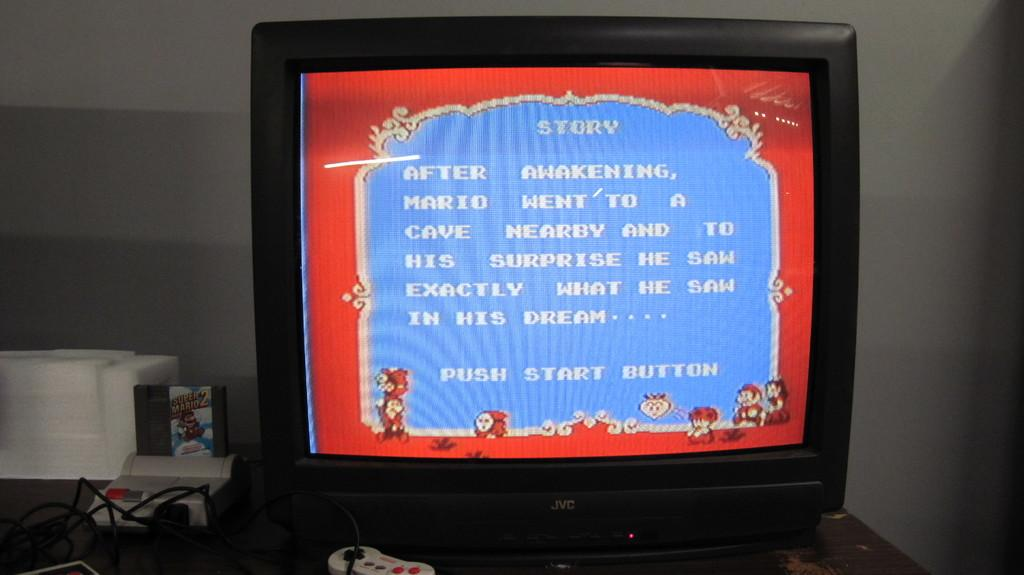<image>
Summarize the visual content of the image. An old style computer sits next to a bulky monitor which displays arcade type text concerning the games story. 